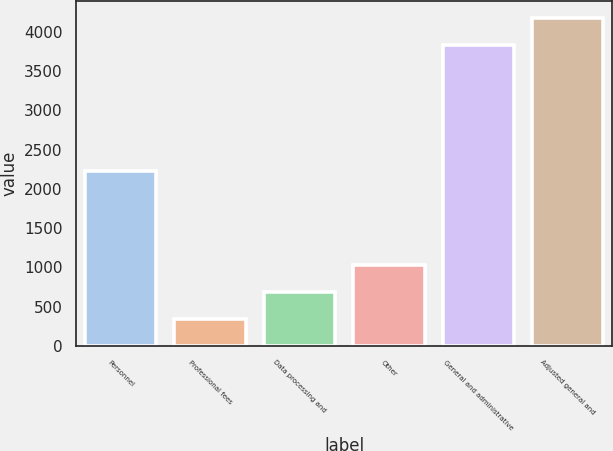<chart> <loc_0><loc_0><loc_500><loc_500><bar_chart><fcel>Personnel<fcel>Professional fees<fcel>Data processing and<fcel>Other<fcel>General and administrative<fcel>Adjusted general and<nl><fcel>2225<fcel>337<fcel>686<fcel>1035<fcel>3827<fcel>4176<nl></chart> 